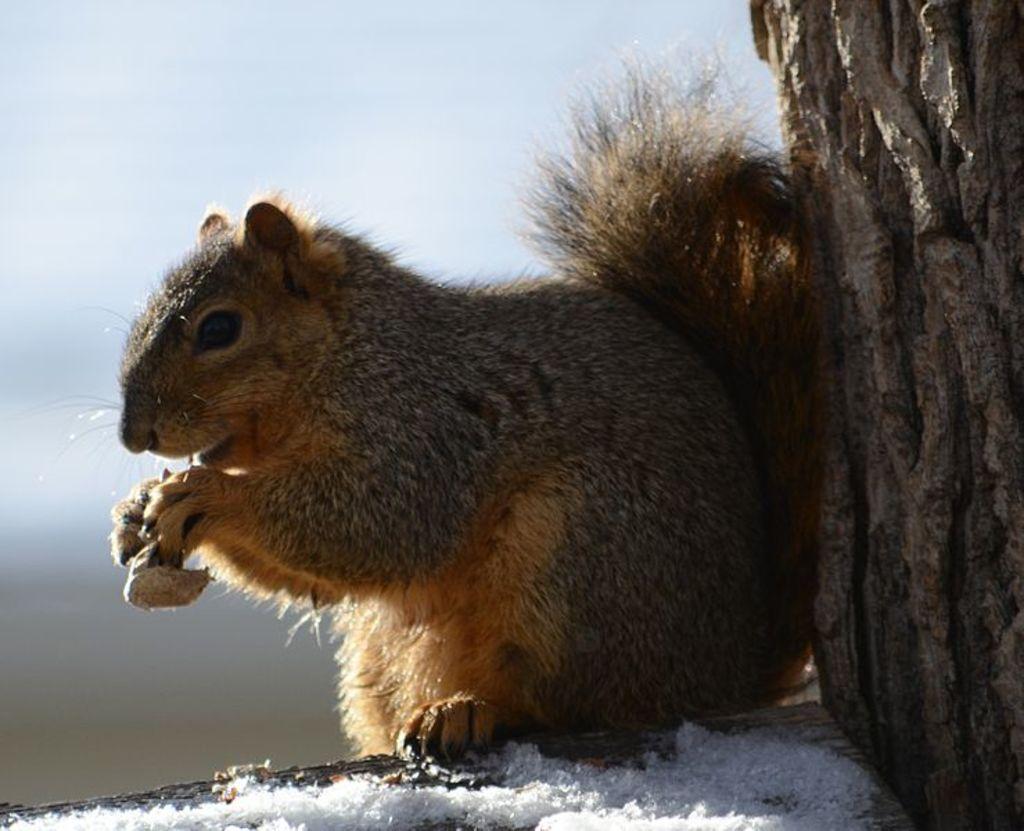Could you give a brief overview of what you see in this image? In this image we can see a squirrel and it is holding something in the hands. 